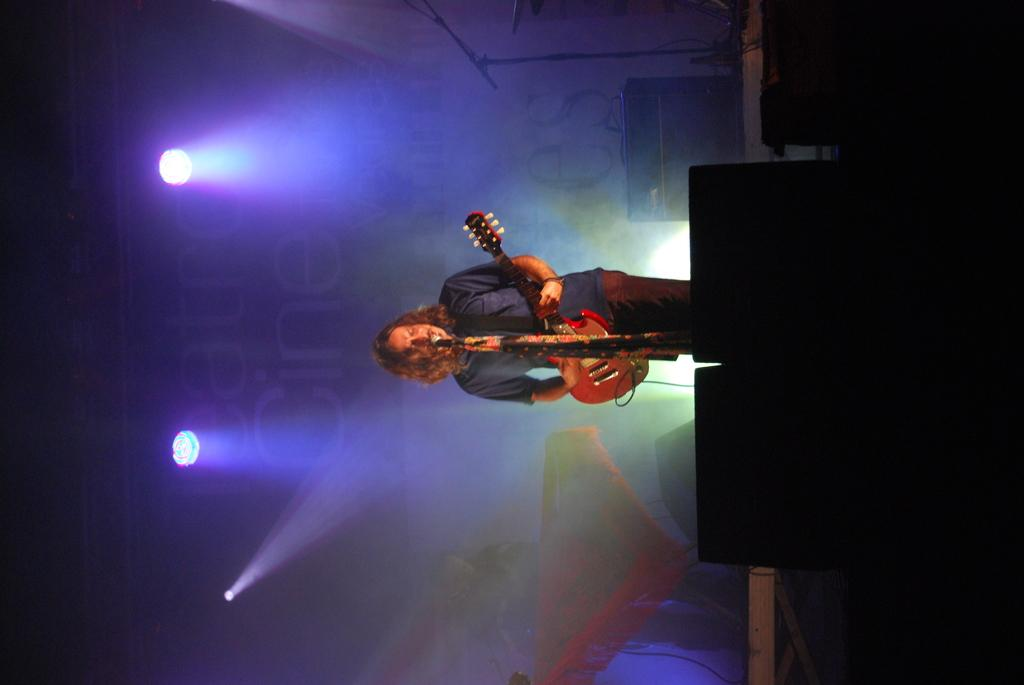What is the man in the image doing? The man is standing, playing the guitar, and singing into a microphone. What is the man holding in his hand? The man is holding a guitar in his hand. Can you describe the background of the image? There are other people, lighting, and a banner visible in the background. What type of table is the man using to play the guitar in the image? There is no table present in the image; the man is standing while playing the guitar. What color is the stocking on the man's leg in the image? The man is not wearing a stocking in the image, and there is no mention of any clothing item on his leg. 